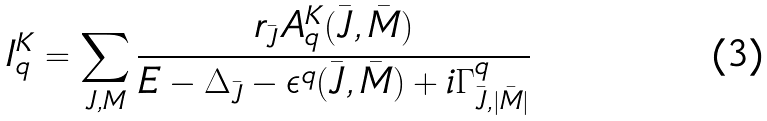<formula> <loc_0><loc_0><loc_500><loc_500>I _ { q } ^ { K } = \sum _ { J , M } \frac { r _ { \bar { J } } A _ { q } ^ { K } ( \bar { J } , \bar { M } ) } { E - \Delta _ { \bar { J } } - \epsilon ^ { q } ( \bar { J } , \bar { M } ) + i \Gamma _ { \bar { J } , | \bar { M } | } ^ { q } }</formula> 